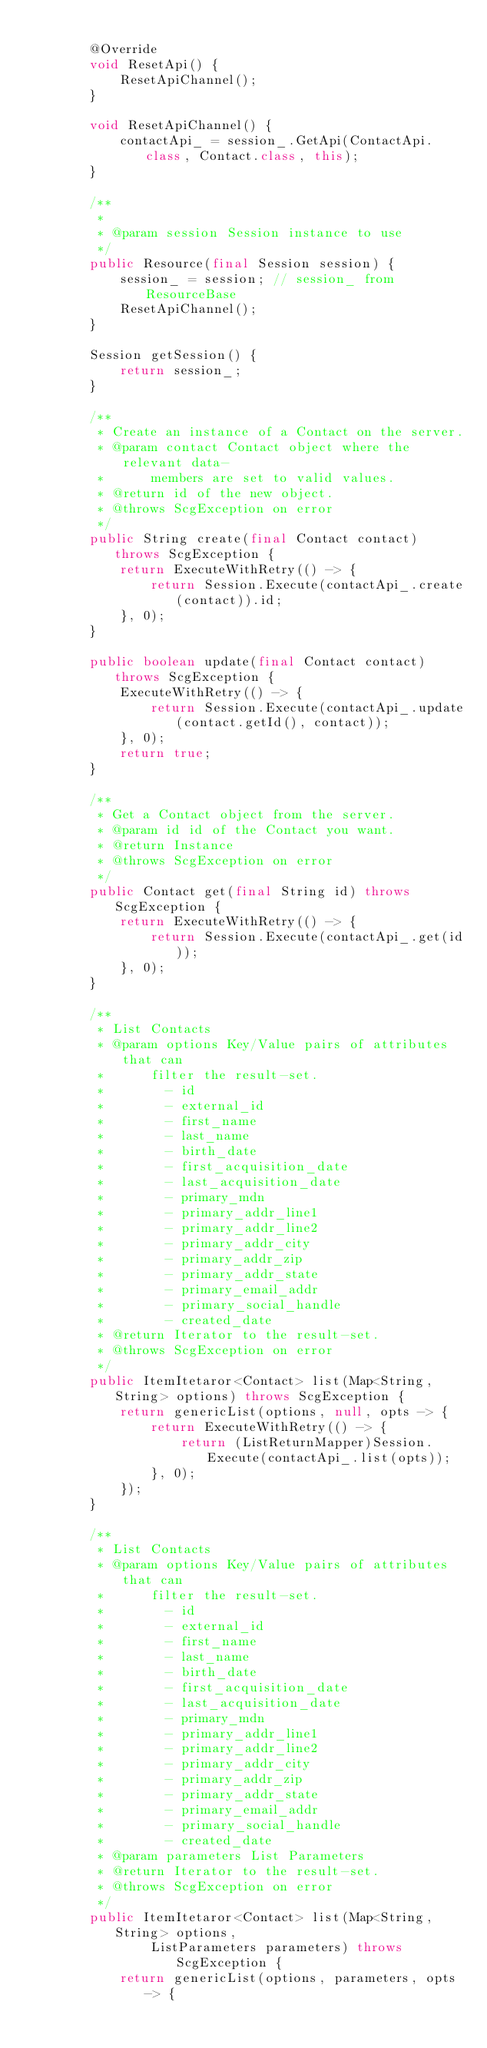Convert code to text. <code><loc_0><loc_0><loc_500><loc_500><_Java_>
        @Override
        void ResetApi() {
            ResetApiChannel();
        }

        void ResetApiChannel() {
            contactApi_ = session_.GetApi(ContactApi.class, Contact.class, this);
        }

        /**
         *
         * @param session Session instance to use
         */
        public Resource(final Session session) {
            session_ = session; // session_ from ResourceBase
            ResetApiChannel();
        }

        Session getSession() {
            return session_;
        }

        /**
         * Create an instance of a Contact on the server.
         * @param contact Contact object where the relevant data-
         *      members are set to valid values.
         * @return id of the new object.
         * @throws ScgException on error
         */
        public String create(final Contact contact) throws ScgException {
            return ExecuteWithRetry(() -> {
                return Session.Execute(contactApi_.create(contact)).id;
            }, 0);
        }

        public boolean update(final Contact contact) throws ScgException {
            ExecuteWithRetry(() -> {
                return Session.Execute(contactApi_.update(contact.getId(), contact));
            }, 0);
            return true;
        }

        /**
         * Get a Contact object from the server.
         * @param id id of the Contact you want.
         * @return Instance
         * @throws ScgException on error
         */
        public Contact get(final String id) throws ScgException {
            return ExecuteWithRetry(() -> {
                return Session.Execute(contactApi_.get(id));
            }, 0);
        }

        /**
         * List Contacts
         * @param options Key/Value pairs of attributes that can
         *      filter the result-set.
         *        - id
         *        - external_id
         *        - first_name
         *        - last_name
         *        - birth_date
         *        - first_acquisition_date
         *        - last_acquisition_date
         *        - primary_mdn
         *        - primary_addr_line1
         *        - primary_addr_line2
         *        - primary_addr_city
         *        - primary_addr_zip
         *        - primary_addr_state
         *        - primary_email_addr
         *        - primary_social_handle
         *        - created_date
         * @return Iterator to the result-set.
         * @throws ScgException on error
         */
        public ItemItetaror<Contact> list(Map<String, String> options) throws ScgException {
            return genericList(options, null, opts -> {
                return ExecuteWithRetry(() -> {
                    return (ListReturnMapper)Session.Execute(contactApi_.list(opts));
                }, 0);
            });
        }

        /**
         * List Contacts
         * @param options Key/Value pairs of attributes that can
         *      filter the result-set.
         *        - id
         *        - external_id
         *        - first_name
         *        - last_name
         *        - birth_date
         *        - first_acquisition_date
         *        - last_acquisition_date
         *        - primary_mdn
         *        - primary_addr_line1
         *        - primary_addr_line2
         *        - primary_addr_city
         *        - primary_addr_zip
         *        - primary_addr_state
         *        - primary_email_addr
         *        - primary_social_handle
         *        - created_date
         * @param parameters List Parameters
         * @return Iterator to the result-set.
         * @throws ScgException on error
         */
        public ItemItetaror<Contact> list(Map<String, String> options,
                ListParameters parameters) throws ScgException {
            return genericList(options, parameters, opts -> {</code> 